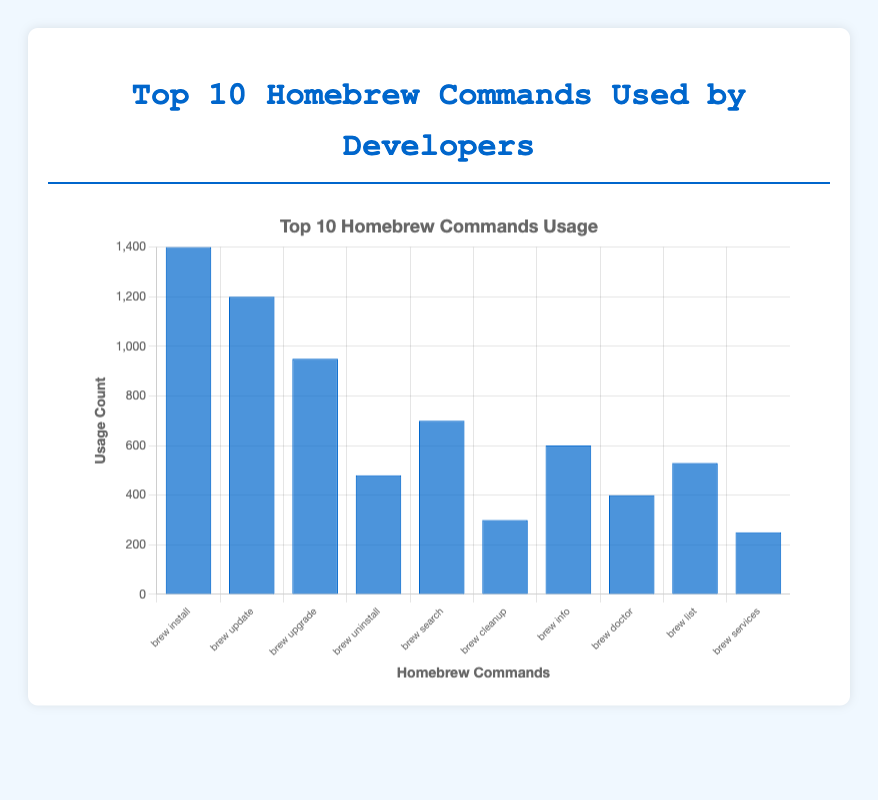What is the most frequently used Homebrew command among developers? The chart shows the usage counts of various Homebrew commands. The highest bar corresponds to "brew install" with a count of 1400, making it the most frequently used command.
Answer: brew install How many more times is "brew update" used compared to "brew cleanup"? "brew update" has a usage count of 1200, while "brew cleanup" has 300. The difference between their counts is 1200 - 300 = 900.
Answer: 900 Which Homebrew command is used the least, and what is its usage count? The shortest bar represents "brew services," which has the lowest count of 250.
Answer: brew services, 250 What is the total usage count for "brew install," "brew update," and "brew upgrade"? Adding the usage counts of "brew install" (1400), "brew update" (1200), and "brew upgrade" (950): 1400 + 1200 + 950 = 3550.
Answer: 3550 What is the average usage count of all the Homebrew commands listed? Adding all usage counts: 1400 + 1200 + 950 + 480 + 700 + 300 + 600 + 400 + 530 + 250 = 6810. Dividing by the number of commands (10): 6810 / 10 = 681.
Answer: 681 Is "brew list" used more frequently than "brew uninstall"? "brew list" has a count of 530, while "brew uninstall" has 480. Since 530 > 480, "brew list" is used more frequently.
Answer: Yes What is the combined usage count of the three least used commands? The three least used commands are "brew services" (250), "brew cleanup" (300), and "brew doctor" (400). Their combined count is 250 + 300 + 400 = 950.
Answer: 950 By how much does the usage count of "brew info" exceed that of "brew doctor"? "brew info" has a count of 600, while "brew doctor" has 400. The difference is 600 - 400 = 200.
Answer: 200 Which commands have a usage count greater than or equal to 1000? From the chart, "brew install" (1400) and "brew update" (1200) have usage counts greater than 1000.
Answer: brew install, brew update 